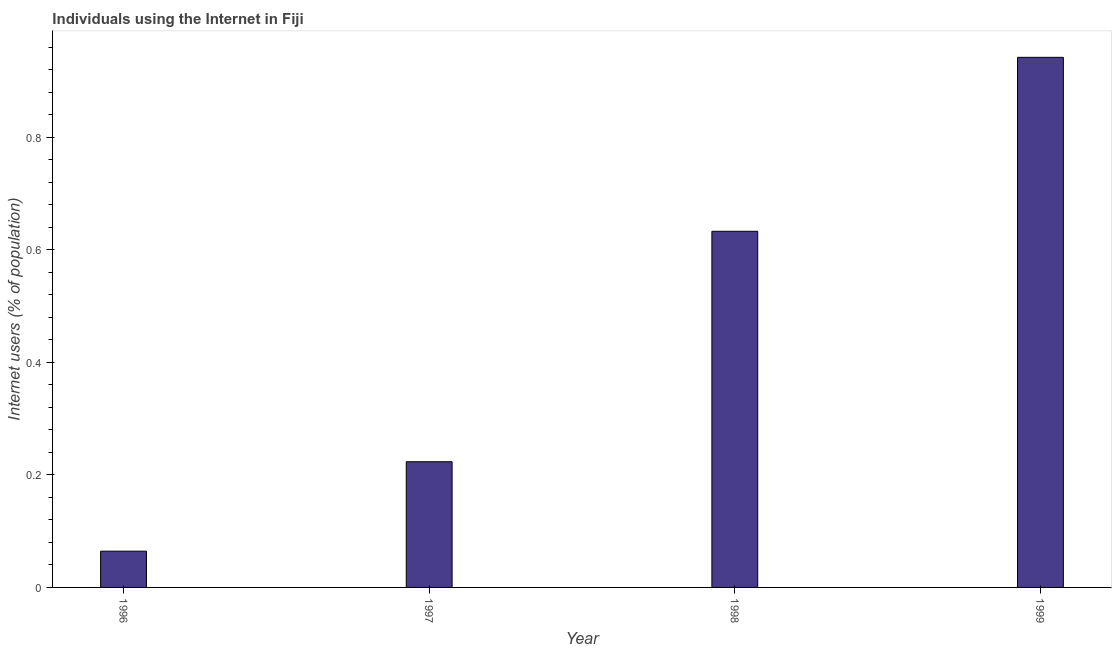Does the graph contain any zero values?
Your answer should be compact. No. Does the graph contain grids?
Ensure brevity in your answer.  No. What is the title of the graph?
Your response must be concise. Individuals using the Internet in Fiji. What is the label or title of the Y-axis?
Your answer should be compact. Internet users (% of population). What is the number of internet users in 1996?
Give a very brief answer. 0.06. Across all years, what is the maximum number of internet users?
Give a very brief answer. 0.94. Across all years, what is the minimum number of internet users?
Offer a very short reply. 0.06. In which year was the number of internet users maximum?
Provide a succinct answer. 1999. In which year was the number of internet users minimum?
Give a very brief answer. 1996. What is the sum of the number of internet users?
Give a very brief answer. 1.86. What is the difference between the number of internet users in 1996 and 1999?
Your response must be concise. -0.88. What is the average number of internet users per year?
Offer a very short reply. 0.47. What is the median number of internet users?
Ensure brevity in your answer.  0.43. Do a majority of the years between 1998 and 1997 (inclusive) have number of internet users greater than 0.92 %?
Make the answer very short. No. What is the ratio of the number of internet users in 1997 to that in 1999?
Keep it short and to the point. 0.24. Is the difference between the number of internet users in 1996 and 1997 greater than the difference between any two years?
Offer a very short reply. No. What is the difference between the highest and the second highest number of internet users?
Offer a terse response. 0.31. Is the sum of the number of internet users in 1996 and 1999 greater than the maximum number of internet users across all years?
Offer a very short reply. Yes. What is the difference between the highest and the lowest number of internet users?
Give a very brief answer. 0.88. In how many years, is the number of internet users greater than the average number of internet users taken over all years?
Your answer should be very brief. 2. How many bars are there?
Give a very brief answer. 4. Are all the bars in the graph horizontal?
Give a very brief answer. No. How many years are there in the graph?
Your answer should be compact. 4. Are the values on the major ticks of Y-axis written in scientific E-notation?
Give a very brief answer. No. What is the Internet users (% of population) of 1996?
Provide a short and direct response. 0.06. What is the Internet users (% of population) in 1997?
Make the answer very short. 0.22. What is the Internet users (% of population) in 1998?
Offer a very short reply. 0.63. What is the Internet users (% of population) of 1999?
Keep it short and to the point. 0.94. What is the difference between the Internet users (% of population) in 1996 and 1997?
Provide a short and direct response. -0.16. What is the difference between the Internet users (% of population) in 1996 and 1998?
Keep it short and to the point. -0.57. What is the difference between the Internet users (% of population) in 1996 and 1999?
Keep it short and to the point. -0.88. What is the difference between the Internet users (% of population) in 1997 and 1998?
Keep it short and to the point. -0.41. What is the difference between the Internet users (% of population) in 1997 and 1999?
Offer a terse response. -0.72. What is the difference between the Internet users (% of population) in 1998 and 1999?
Offer a very short reply. -0.31. What is the ratio of the Internet users (% of population) in 1996 to that in 1997?
Your response must be concise. 0.29. What is the ratio of the Internet users (% of population) in 1996 to that in 1998?
Offer a very short reply. 0.1. What is the ratio of the Internet users (% of population) in 1996 to that in 1999?
Provide a short and direct response. 0.07. What is the ratio of the Internet users (% of population) in 1997 to that in 1998?
Your answer should be very brief. 0.35. What is the ratio of the Internet users (% of population) in 1997 to that in 1999?
Your answer should be compact. 0.24. What is the ratio of the Internet users (% of population) in 1998 to that in 1999?
Make the answer very short. 0.67. 